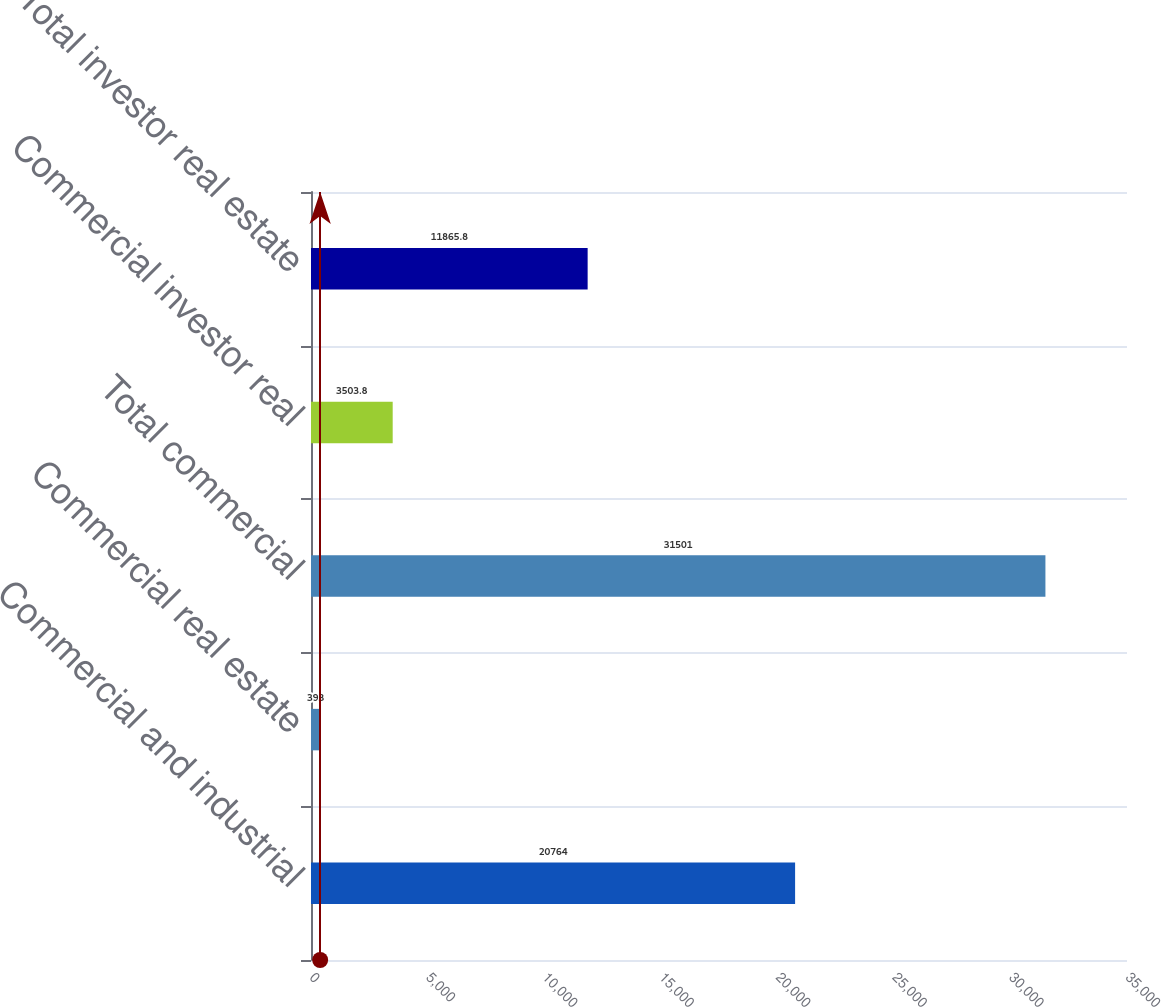<chart> <loc_0><loc_0><loc_500><loc_500><bar_chart><fcel>Commercial and industrial<fcel>Commercial real estate<fcel>Total commercial<fcel>Commercial investor real<fcel>Total investor real estate<nl><fcel>20764<fcel>393<fcel>31501<fcel>3503.8<fcel>11865.8<nl></chart> 